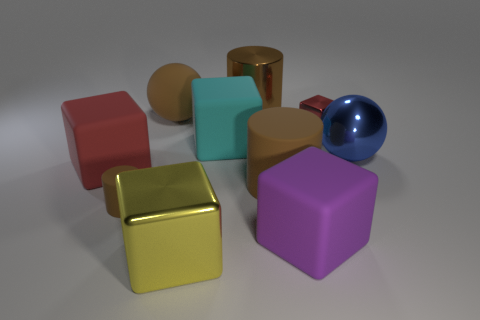Subtract all brown cylinders. How many were subtracted if there are1brown cylinders left? 2 Subtract all yellow spheres. How many red blocks are left? 2 Subtract all cyan blocks. How many blocks are left? 4 Subtract all purple cubes. How many cubes are left? 4 Subtract 1 cylinders. How many cylinders are left? 2 Subtract all yellow blocks. Subtract all purple cylinders. How many blocks are left? 4 Subtract all cylinders. How many objects are left? 7 Subtract all cylinders. Subtract all tiny blocks. How many objects are left? 6 Add 9 tiny cylinders. How many tiny cylinders are left? 10 Add 2 large blue metal objects. How many large blue metal objects exist? 3 